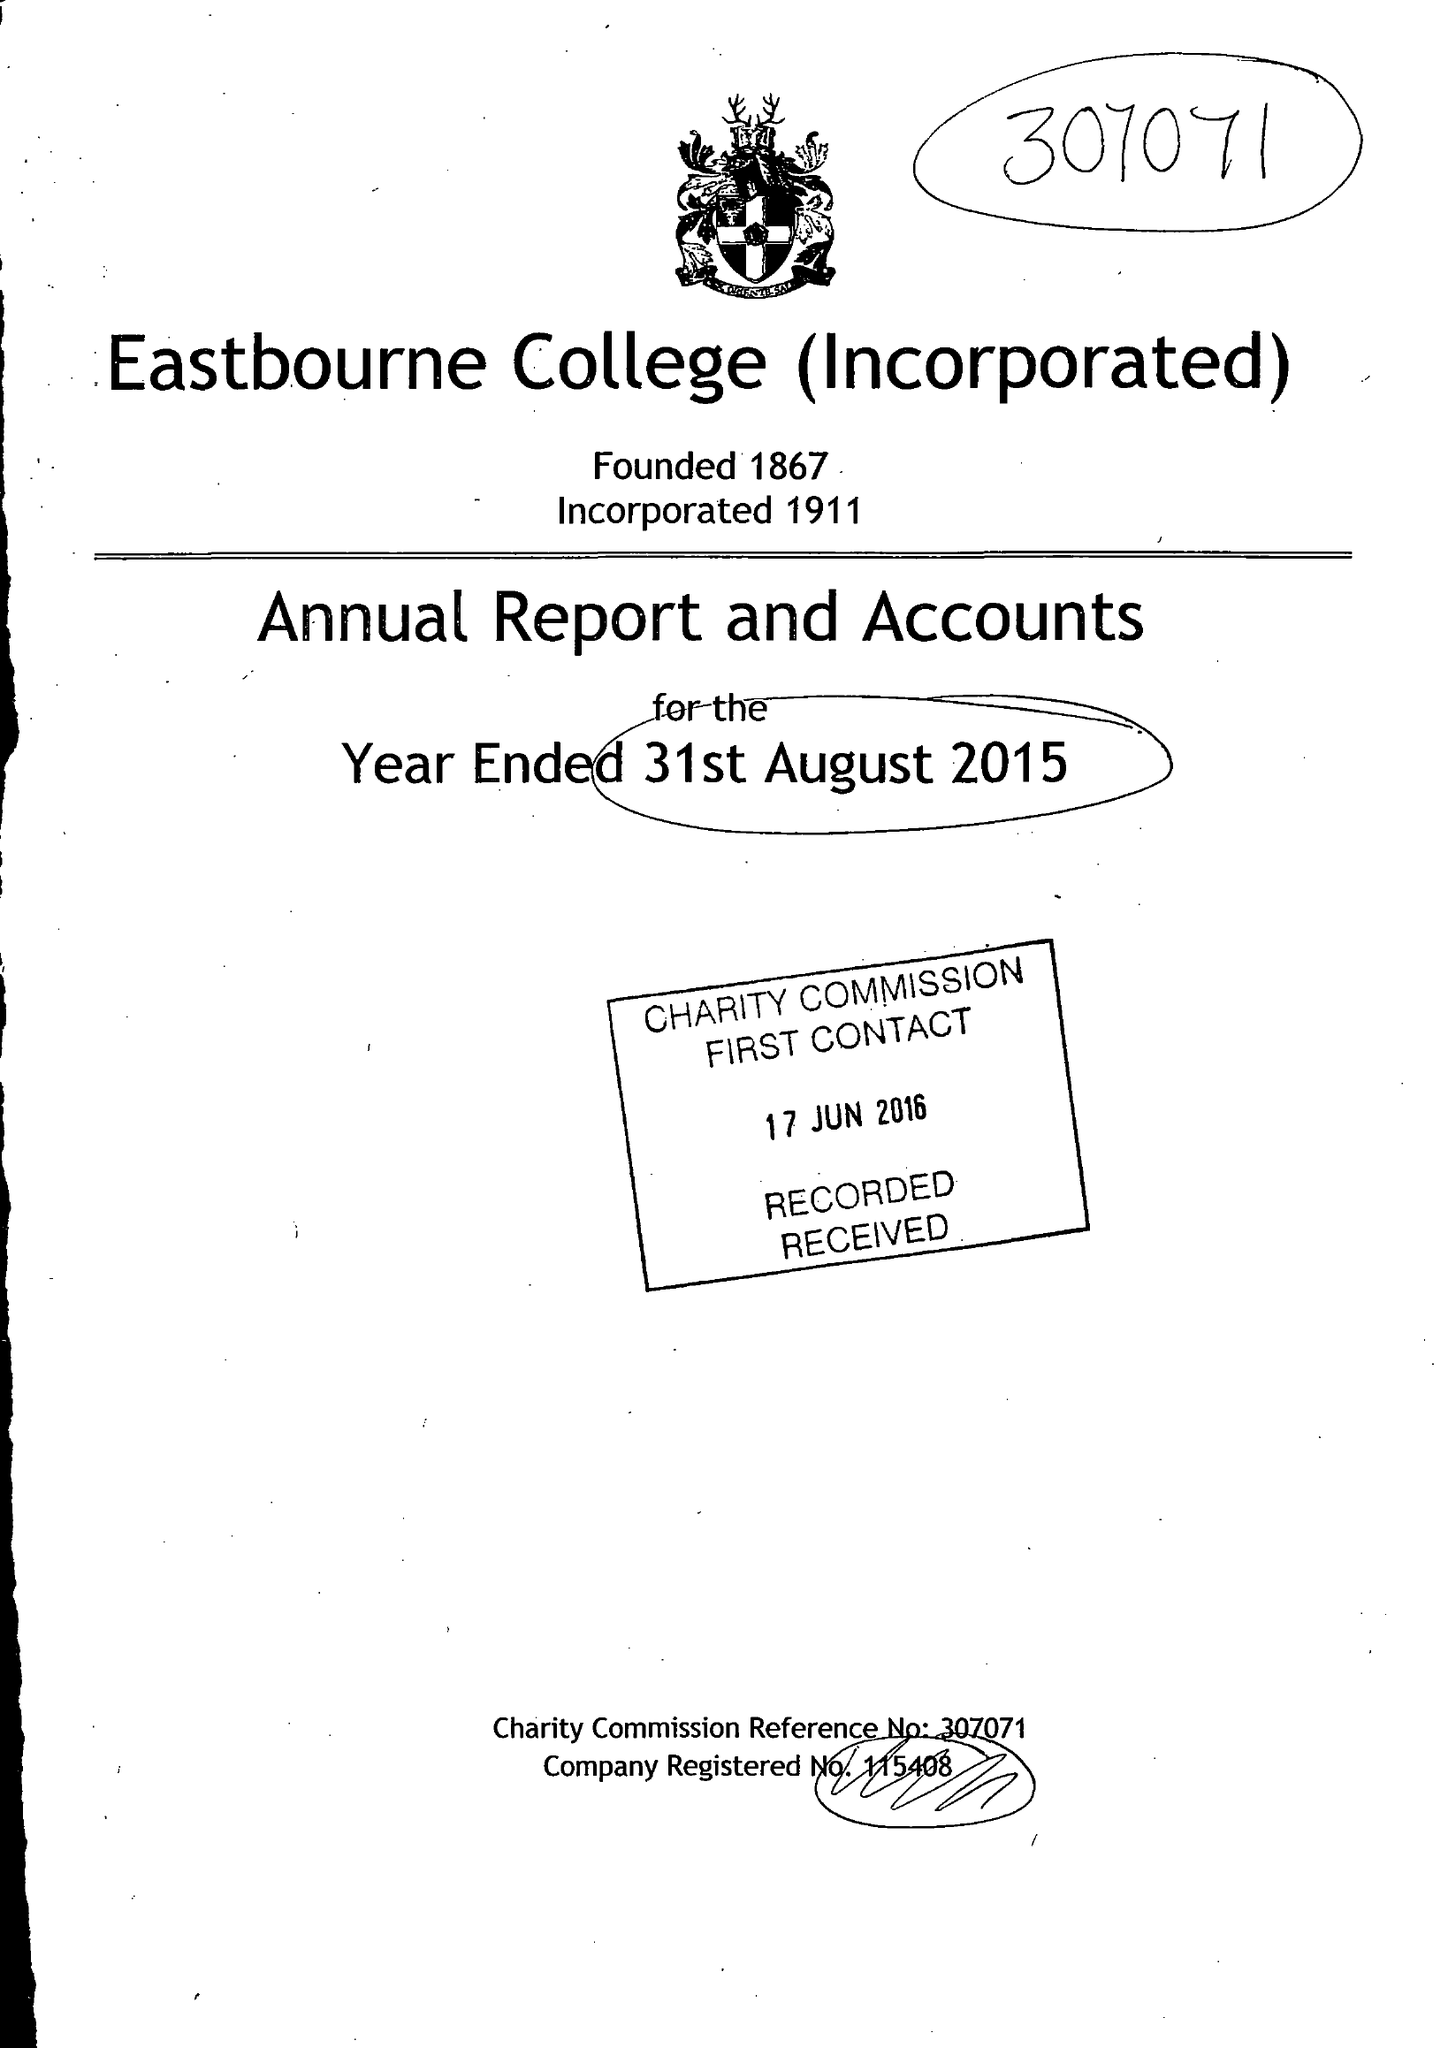What is the value for the address__street_line?
Answer the question using a single word or phrase. OLD WISH ROAD 